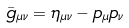<formula> <loc_0><loc_0><loc_500><loc_500>\bar { g } _ { \mu \nu } = \eta _ { \mu \nu } - p _ { \mu } p _ { \nu }</formula> 